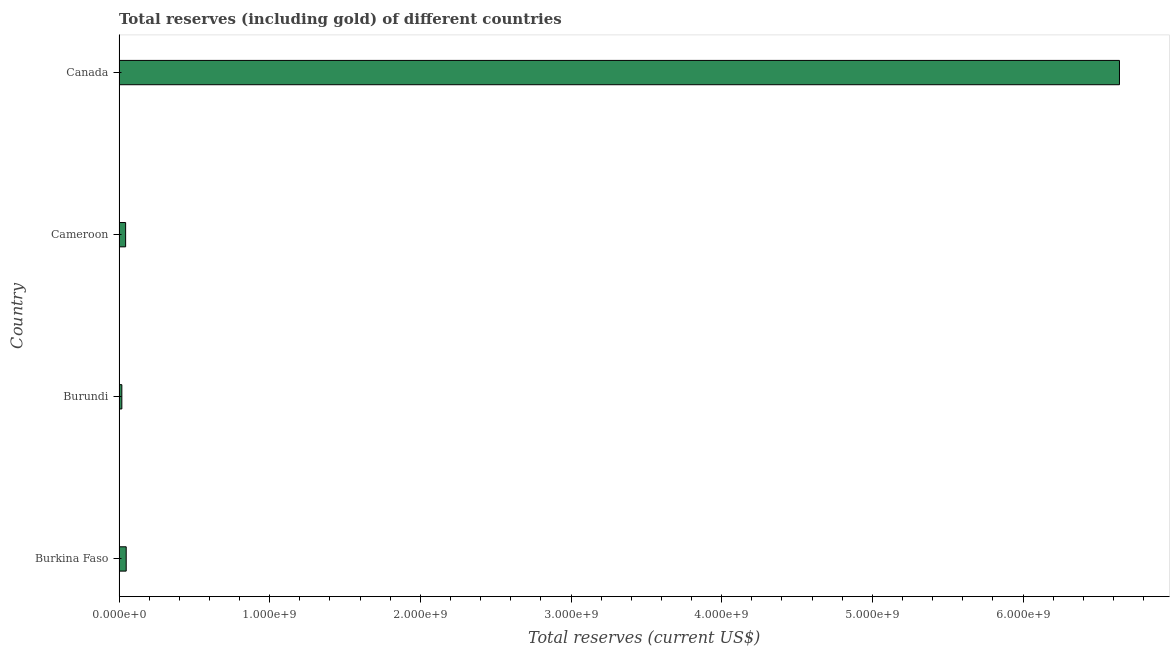Does the graph contain grids?
Make the answer very short. No. What is the title of the graph?
Ensure brevity in your answer.  Total reserves (including gold) of different countries. What is the label or title of the X-axis?
Give a very brief answer. Total reserves (current US$). What is the total reserves (including gold) in Burundi?
Ensure brevity in your answer.  1.85e+07. Across all countries, what is the maximum total reserves (including gold)?
Give a very brief answer. 6.64e+09. Across all countries, what is the minimum total reserves (including gold)?
Offer a terse response. 1.85e+07. In which country was the total reserves (including gold) minimum?
Ensure brevity in your answer.  Burundi. What is the sum of the total reserves (including gold)?
Your answer should be compact. 6.75e+09. What is the difference between the total reserves (including gold) in Burkina Faso and Cameroon?
Give a very brief answer. 3.84e+06. What is the average total reserves (including gold) per country?
Make the answer very short. 1.69e+09. What is the median total reserves (including gold)?
Offer a terse response. 4.56e+07. What is the ratio of the total reserves (including gold) in Burundi to that in Canada?
Offer a terse response. 0. Is the total reserves (including gold) in Burkina Faso less than that in Canada?
Your response must be concise. Yes. What is the difference between the highest and the second highest total reserves (including gold)?
Offer a terse response. 6.59e+09. Is the sum of the total reserves (including gold) in Burundi and Canada greater than the maximum total reserves (including gold) across all countries?
Give a very brief answer. Yes. What is the difference between the highest and the lowest total reserves (including gold)?
Your answer should be compact. 6.62e+09. How many bars are there?
Offer a very short reply. 4. How many countries are there in the graph?
Provide a short and direct response. 4. What is the Total reserves (current US$) of Burkina Faso?
Your response must be concise. 4.75e+07. What is the Total reserves (current US$) of Burundi?
Provide a succinct answer. 1.85e+07. What is the Total reserves (current US$) of Cameroon?
Provide a short and direct response. 4.36e+07. What is the Total reserves (current US$) in Canada?
Make the answer very short. 6.64e+09. What is the difference between the Total reserves (current US$) in Burkina Faso and Burundi?
Ensure brevity in your answer.  2.89e+07. What is the difference between the Total reserves (current US$) in Burkina Faso and Cameroon?
Give a very brief answer. 3.84e+06. What is the difference between the Total reserves (current US$) in Burkina Faso and Canada?
Offer a very short reply. -6.59e+09. What is the difference between the Total reserves (current US$) in Burundi and Cameroon?
Ensure brevity in your answer.  -2.51e+07. What is the difference between the Total reserves (current US$) in Burundi and Canada?
Your answer should be compact. -6.62e+09. What is the difference between the Total reserves (current US$) in Cameroon and Canada?
Ensure brevity in your answer.  -6.60e+09. What is the ratio of the Total reserves (current US$) in Burkina Faso to that in Burundi?
Keep it short and to the point. 2.56. What is the ratio of the Total reserves (current US$) in Burkina Faso to that in Cameroon?
Provide a succinct answer. 1.09. What is the ratio of the Total reserves (current US$) in Burkina Faso to that in Canada?
Make the answer very short. 0.01. What is the ratio of the Total reserves (current US$) in Burundi to that in Cameroon?
Your answer should be very brief. 0.42. What is the ratio of the Total reserves (current US$) in Burundi to that in Canada?
Your answer should be very brief. 0. What is the ratio of the Total reserves (current US$) in Cameroon to that in Canada?
Ensure brevity in your answer.  0.01. 